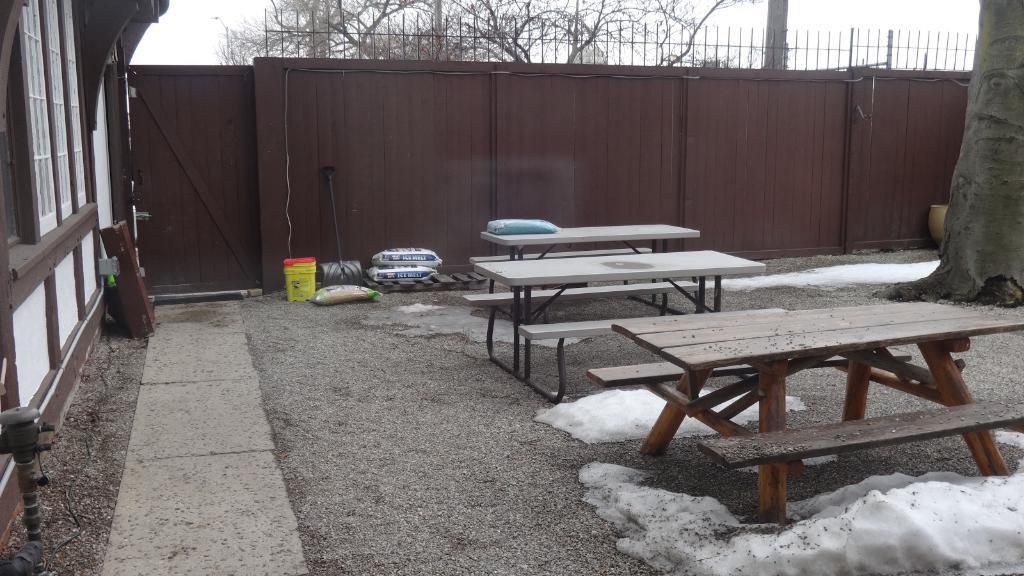Could you give a brief overview of what you see in this image? In the foreground, I can see benches, snow, bags and some objects on the ground. In the background, I can see a fence, trees, tree trunk and the sky. This image taken, maybe during a day. 